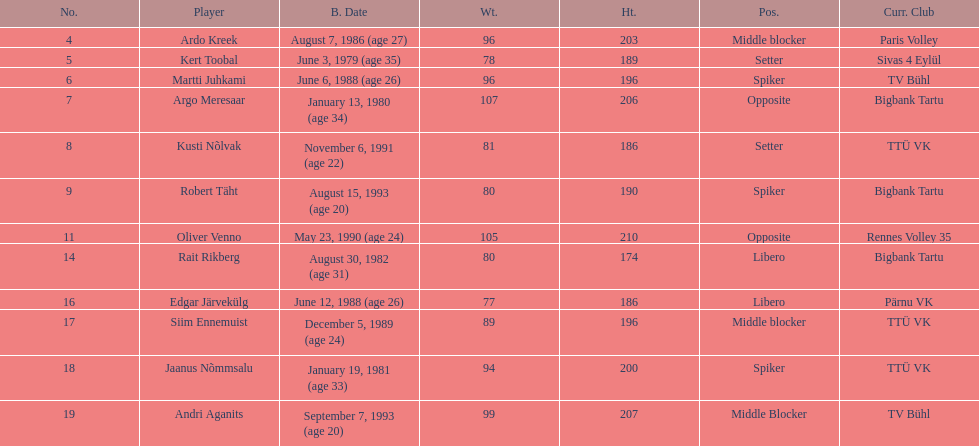How much taller in oliver venno than rait rikberg? 36. 